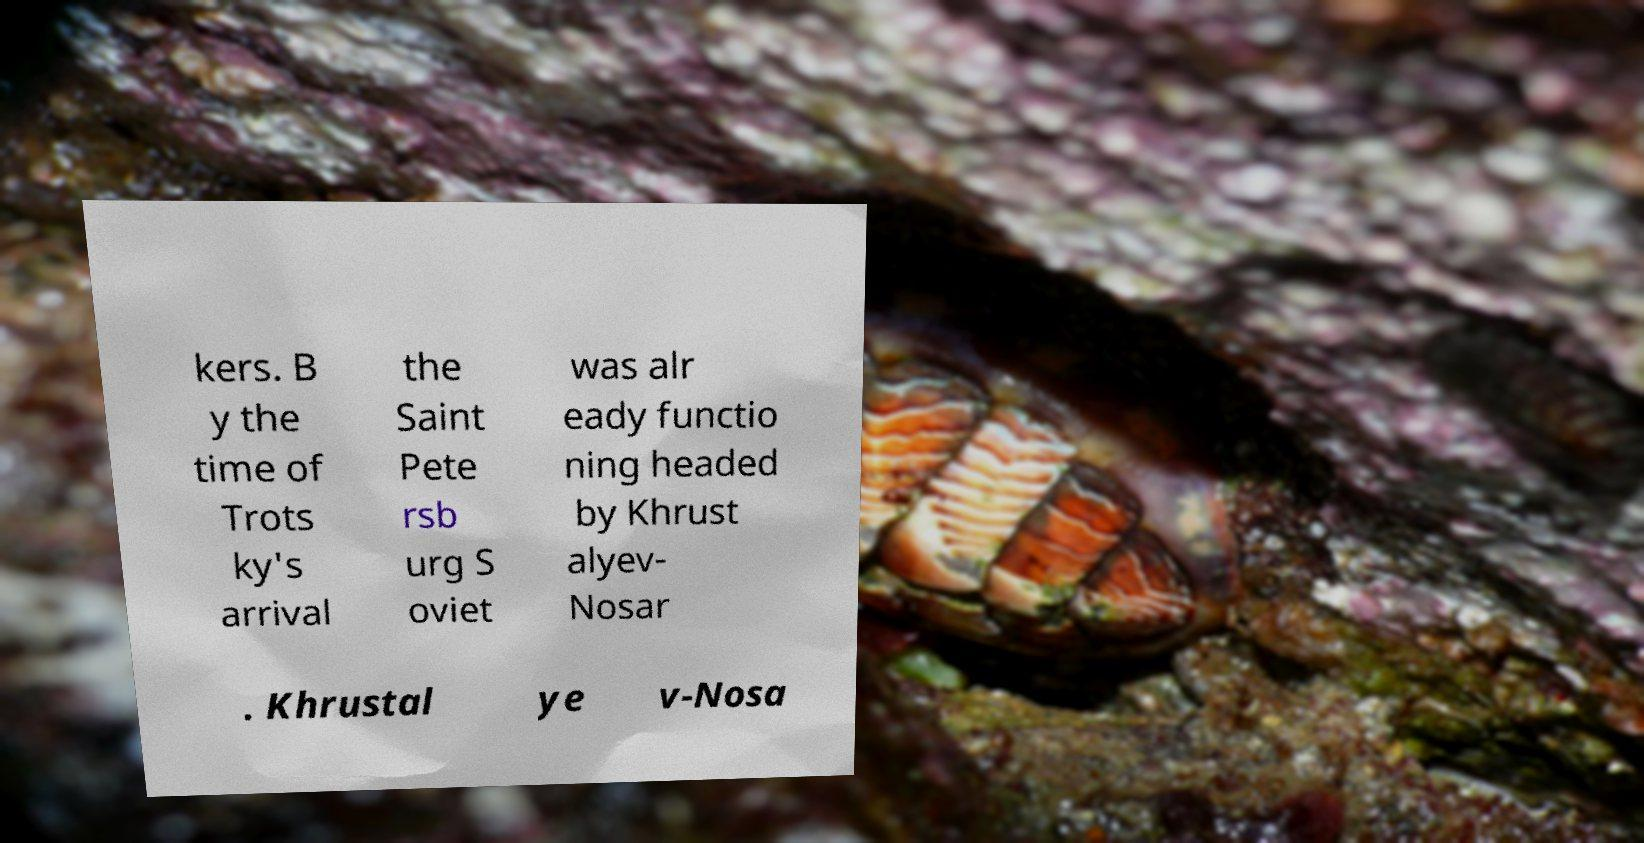For documentation purposes, I need the text within this image transcribed. Could you provide that? kers. B y the time of Trots ky's arrival the Saint Pete rsb urg S oviet was alr eady functio ning headed by Khrust alyev- Nosar . Khrustal ye v-Nosa 